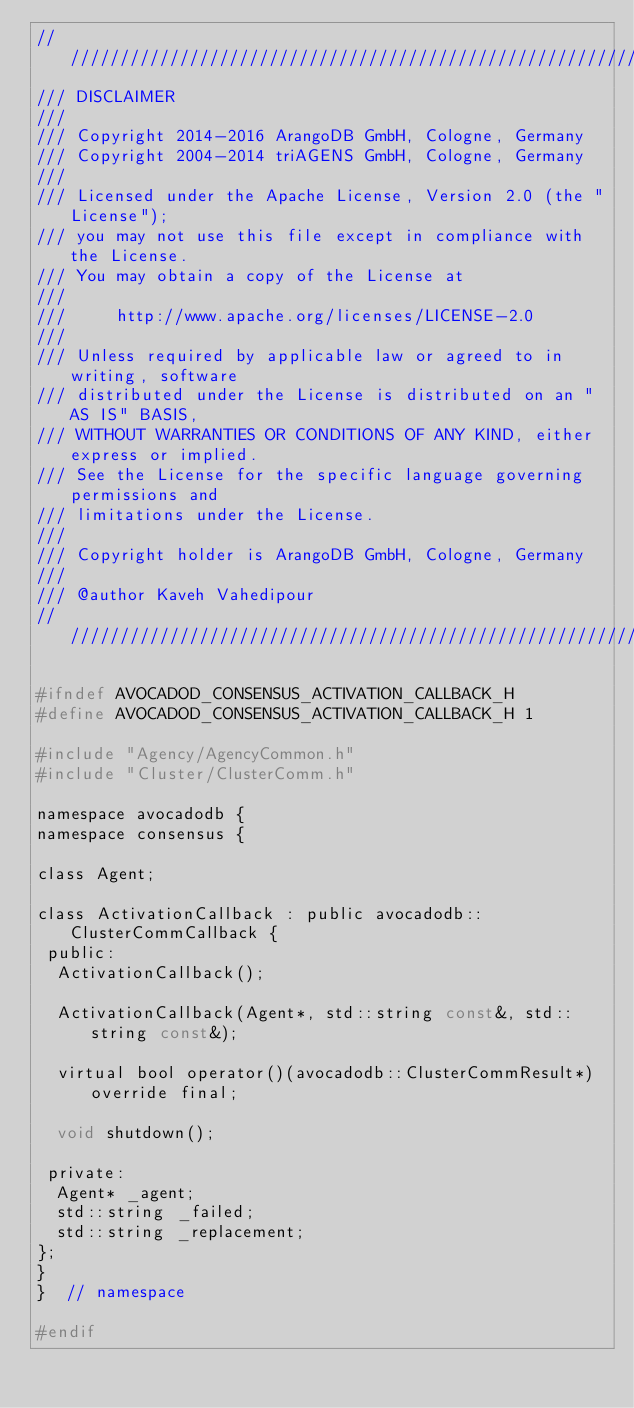Convert code to text. <code><loc_0><loc_0><loc_500><loc_500><_C_>////////////////////////////////////////////////////////////////////////////////
/// DISCLAIMER
///
/// Copyright 2014-2016 ArangoDB GmbH, Cologne, Germany
/// Copyright 2004-2014 triAGENS GmbH, Cologne, Germany
///
/// Licensed under the Apache License, Version 2.0 (the "License");
/// you may not use this file except in compliance with the License.
/// You may obtain a copy of the License at
///
///     http://www.apache.org/licenses/LICENSE-2.0
///
/// Unless required by applicable law or agreed to in writing, software
/// distributed under the License is distributed on an "AS IS" BASIS,
/// WITHOUT WARRANTIES OR CONDITIONS OF ANY KIND, either express or implied.
/// See the License for the specific language governing permissions and
/// limitations under the License.
///
/// Copyright holder is ArangoDB GmbH, Cologne, Germany
///
/// @author Kaveh Vahedipour
////////////////////////////////////////////////////////////////////////////////

#ifndef AVOCADOD_CONSENSUS_ACTIVATION_CALLBACK_H
#define AVOCADOD_CONSENSUS_ACTIVATION_CALLBACK_H 1

#include "Agency/AgencyCommon.h"
#include "Cluster/ClusterComm.h"

namespace avocadodb {
namespace consensus {

class Agent;

class ActivationCallback : public avocadodb::ClusterCommCallback {
 public:
  ActivationCallback();

  ActivationCallback(Agent*, std::string const&, std::string const&);

  virtual bool operator()(avocadodb::ClusterCommResult*) override final;

  void shutdown();

 private:
  Agent* _agent;
  std::string _failed;
  std::string _replacement;
};
}
}  // namespace

#endif
</code> 